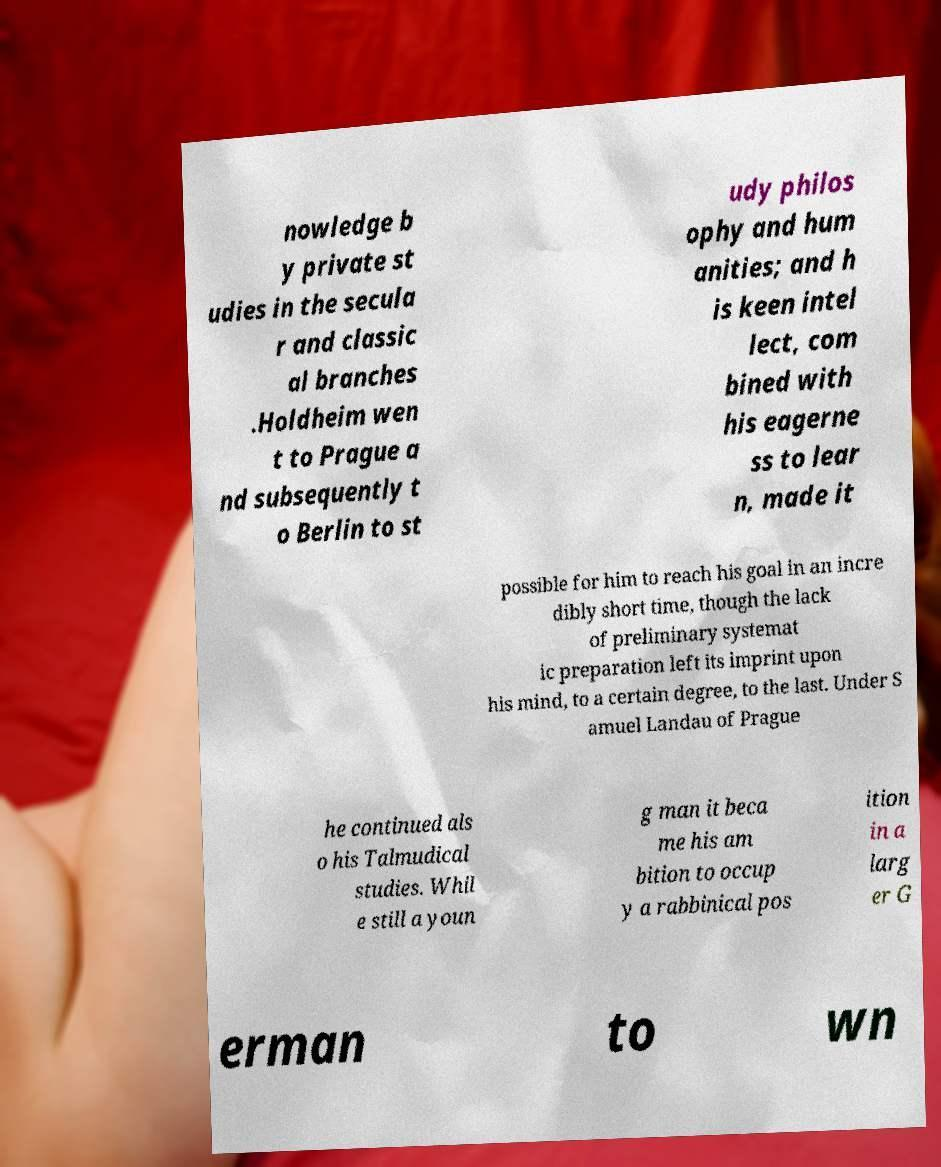What messages or text are displayed in this image? I need them in a readable, typed format. nowledge b y private st udies in the secula r and classic al branches .Holdheim wen t to Prague a nd subsequently t o Berlin to st udy philos ophy and hum anities; and h is keen intel lect, com bined with his eagerne ss to lear n, made it possible for him to reach his goal in an incre dibly short time, though the lack of preliminary systemat ic preparation left its imprint upon his mind, to a certain degree, to the last. Under S amuel Landau of Prague he continued als o his Talmudical studies. Whil e still a youn g man it beca me his am bition to occup y a rabbinical pos ition in a larg er G erman to wn 